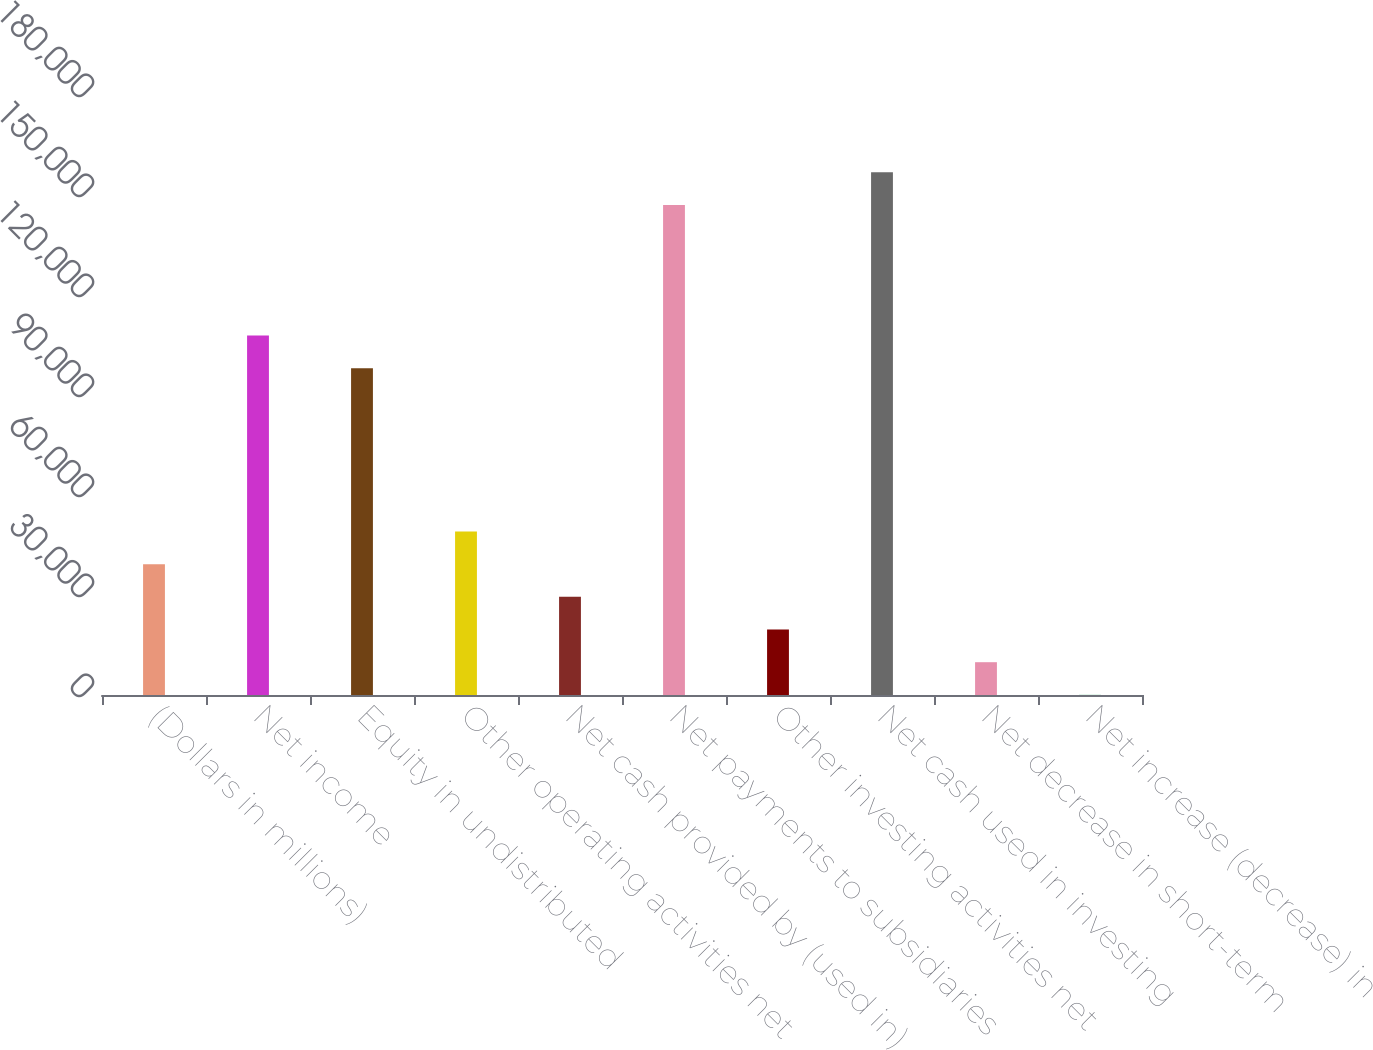<chart> <loc_0><loc_0><loc_500><loc_500><bar_chart><fcel>(Dollars in millions)<fcel>Net income<fcel>Equity in undistributed<fcel>Other operating activities net<fcel>Net cash provided by (used in)<fcel>Net payments to subsidiaries<fcel>Other investing activities net<fcel>Net cash used in investing<fcel>Net decrease in short-term<fcel>Net increase (decrease) in<nl><fcel>39236<fcel>107822<fcel>98024<fcel>49034<fcel>29438<fcel>147014<fcel>19640<fcel>156812<fcel>9842<fcel>44<nl></chart> 